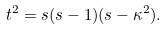<formula> <loc_0><loc_0><loc_500><loc_500>t ^ { 2 } = s ( s - 1 ) ( s - \kappa ^ { 2 } ) .</formula> 